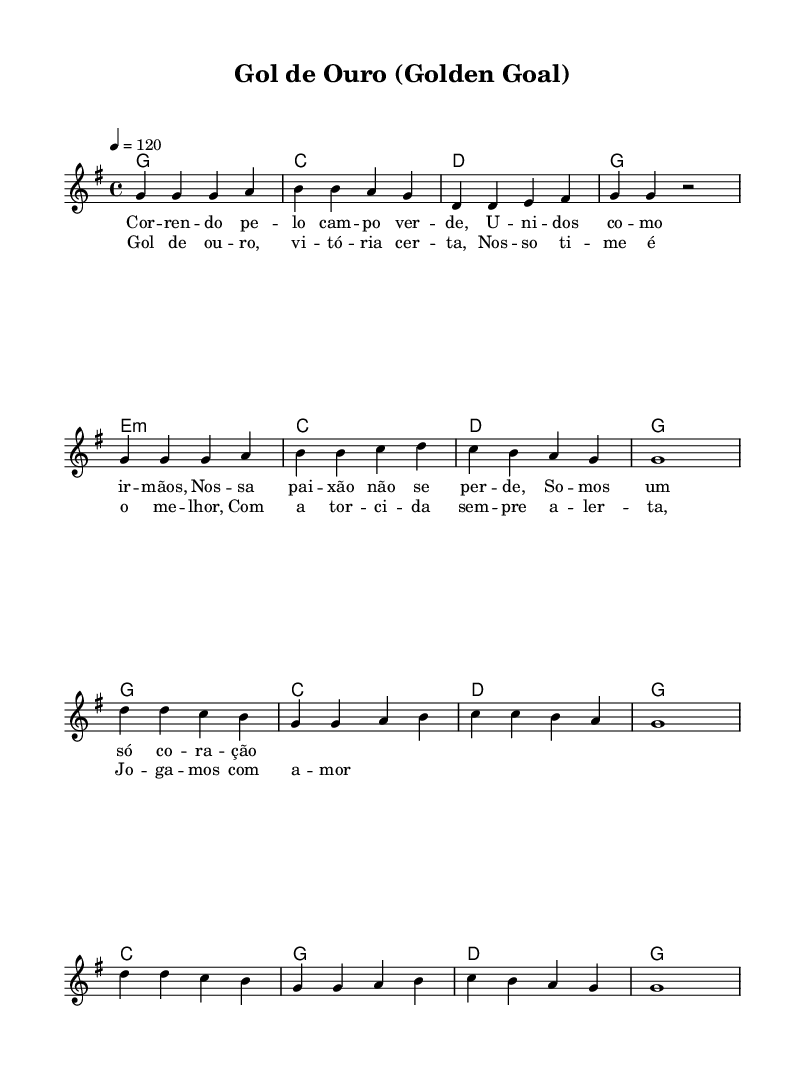What is the key signature of this music? The key signature indicates the pitch relationships of the piece. In this score, it shows one sharp, indicating the key of G major.
Answer: G major What is the time signature of this music? The time signature is located at the beginning of the staff and indicates how many beats are in each measure. In this score, it is shown as 4/4, which means there are four beats per measure.
Answer: 4/4 What is the tempo marking of this music? The tempo is indicated at the start of the piece, noting how fast it should be played. The marking here indicates a tempo of 120 beats per minute.
Answer: 120 How many measures are in the verse? The verse is identified by the lyrics and musical structure.Counting the measures labeled in the melody, there are a total of 8 measures in the verse sections.
Answer: 8 What chord follows the first melody note in the chorus? Looking at the first note of the chorus (D) and its corresponding chord, it is supported by the G major chord, which is indicated in the harmonies section.
Answer: G What is the main lyrical theme of the song? The lyrics suggest a theme of unity and victory in soccer, emphasizing team spirit and community support, characteristic of country rock anthems.
Answer: Unity and victory How does the chorus differ from the verse? While analyzing the structure, the chorus includes a repeated melody with a more uplifting lyrical message about victory, contrasting the introspective tone of the verse.
Answer: Uplifting and repeated 